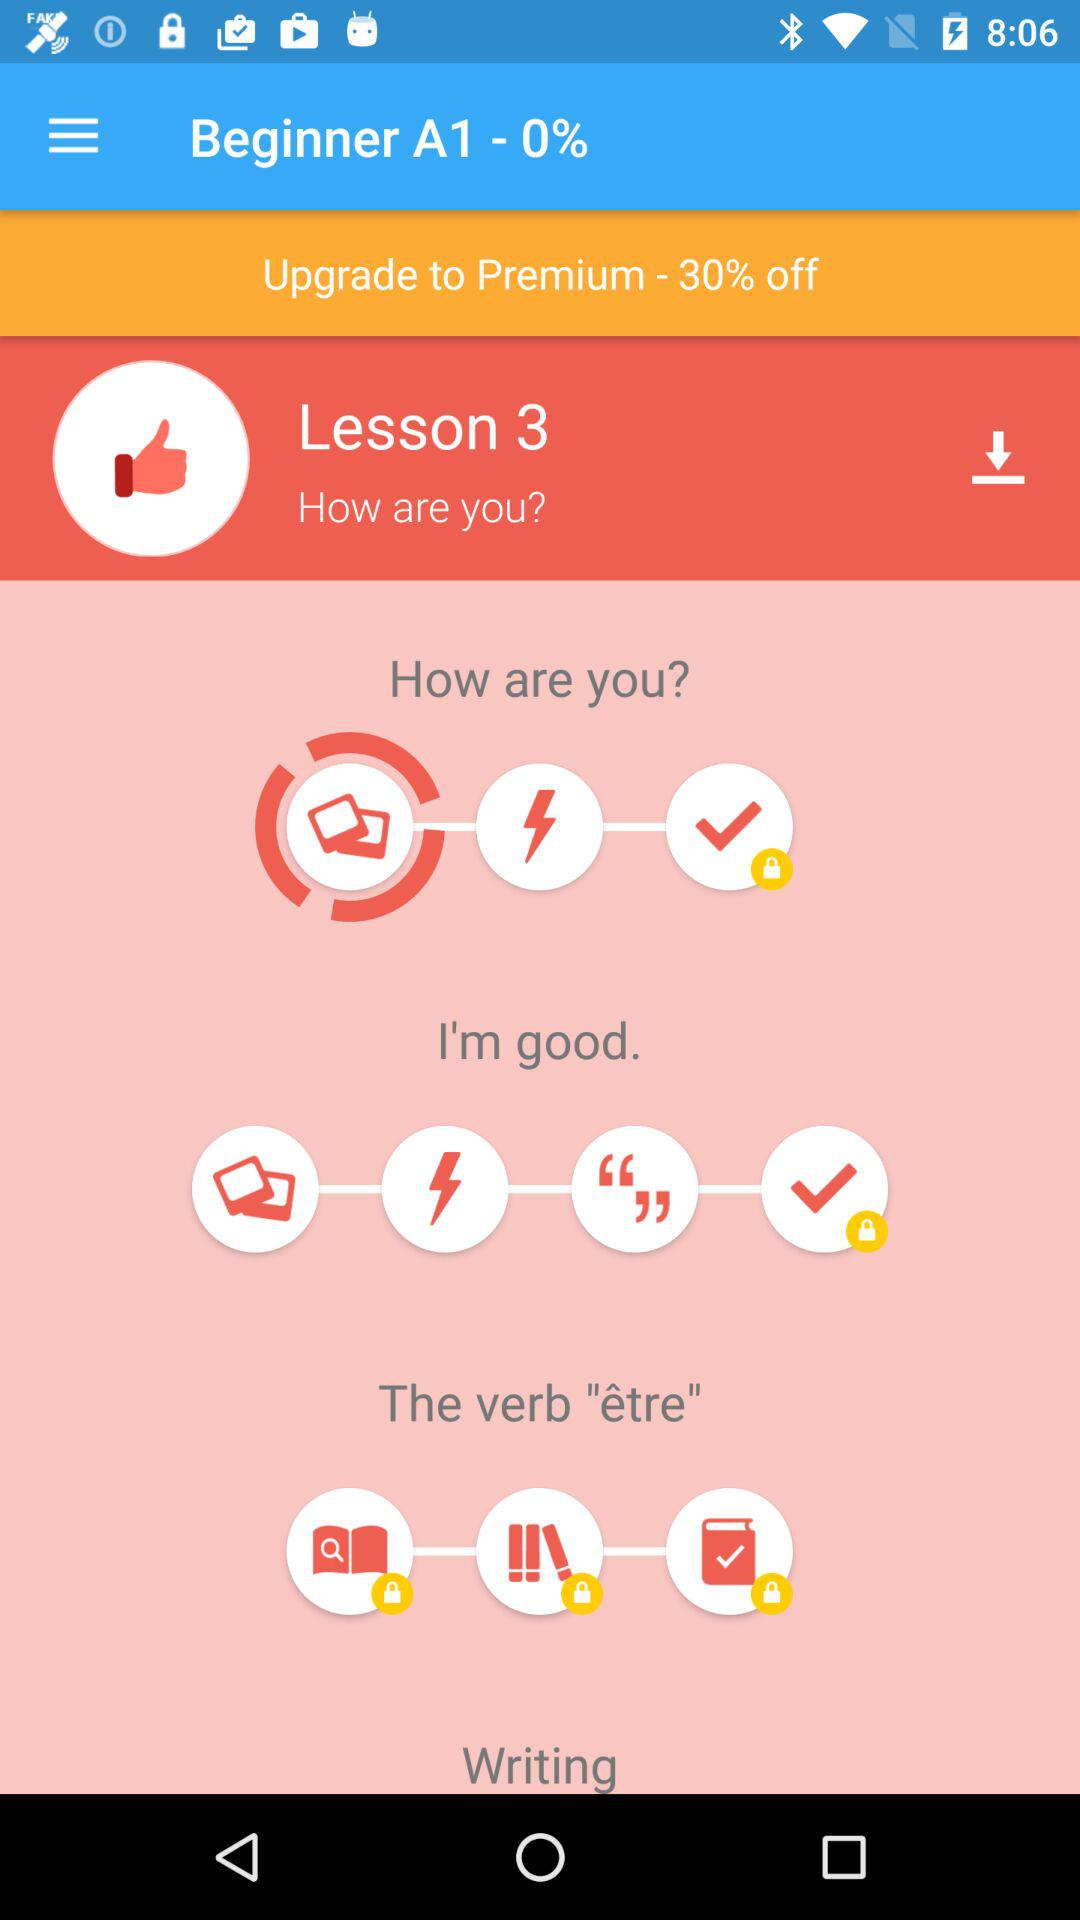How many lessons are available in the French course?
Answer the question using a single word or phrase. 3 